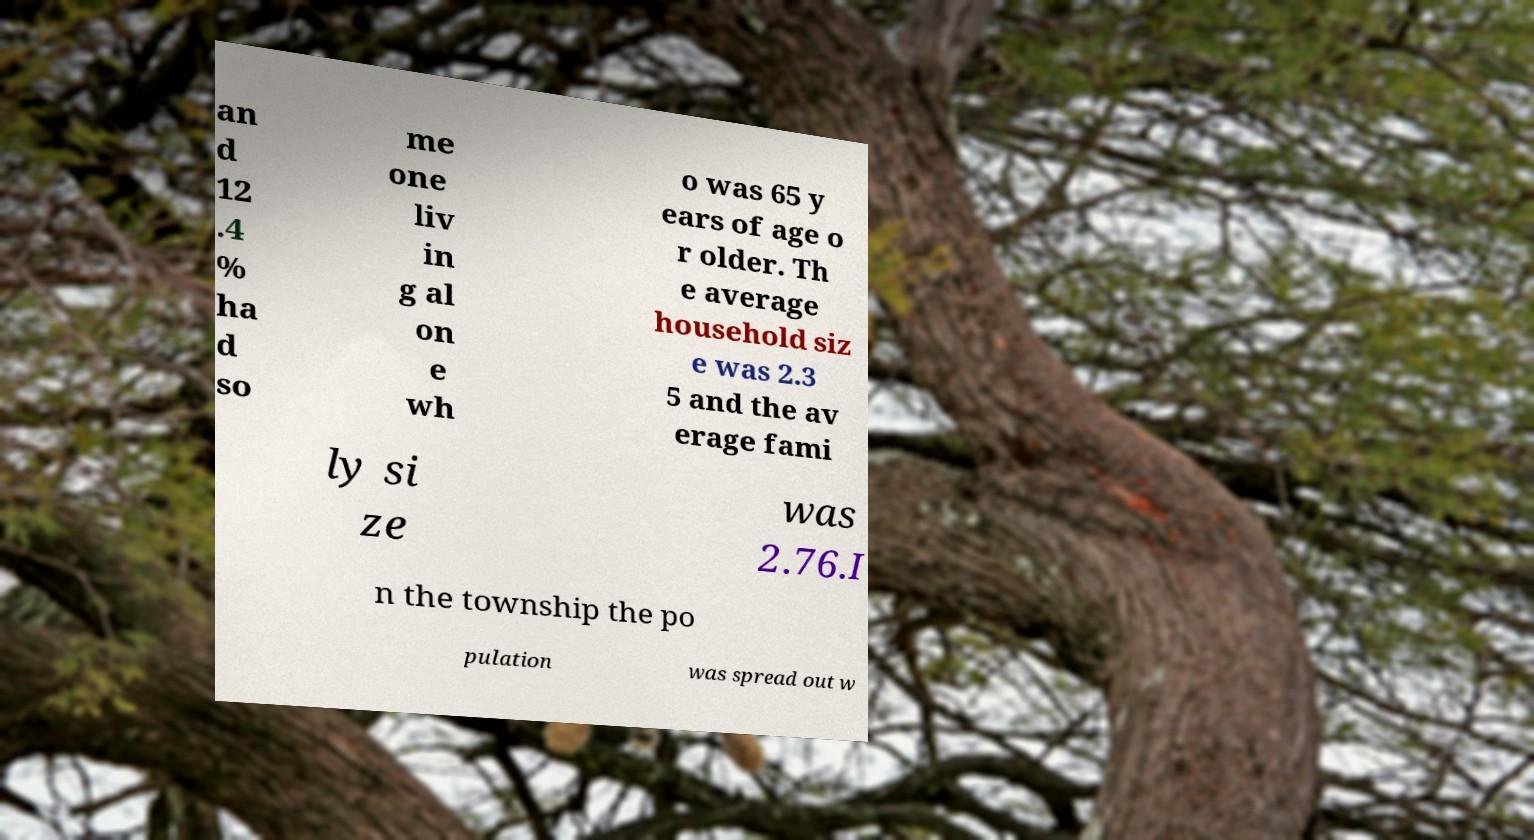Please identify and transcribe the text found in this image. an d 12 .4 % ha d so me one liv in g al on e wh o was 65 y ears of age o r older. Th e average household siz e was 2.3 5 and the av erage fami ly si ze was 2.76.I n the township the po pulation was spread out w 